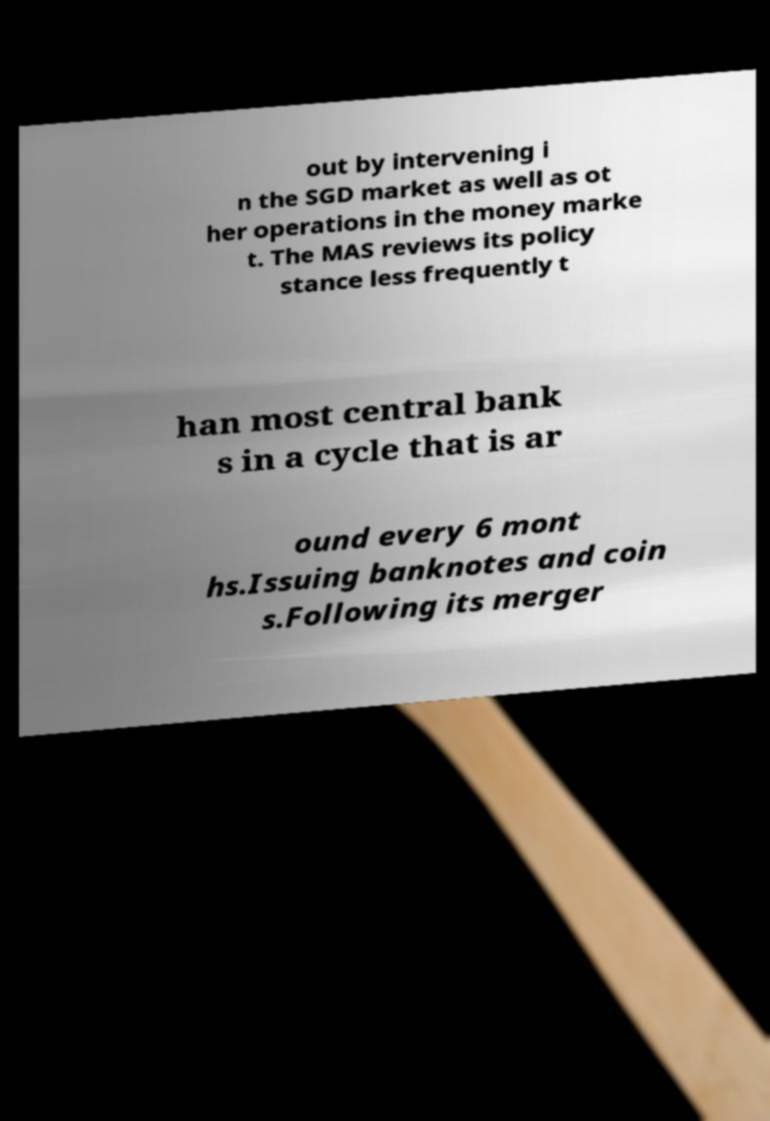What messages or text are displayed in this image? I need them in a readable, typed format. out by intervening i n the SGD market as well as ot her operations in the money marke t. The MAS reviews its policy stance less frequently t han most central bank s in a cycle that is ar ound every 6 mont hs.Issuing banknotes and coin s.Following its merger 